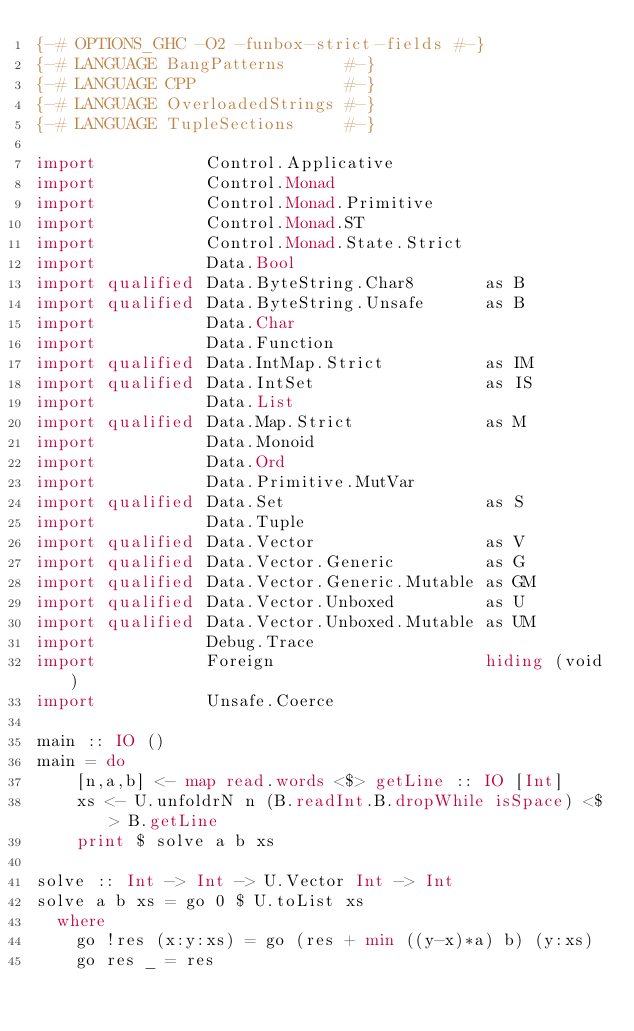Convert code to text. <code><loc_0><loc_0><loc_500><loc_500><_Haskell_>{-# OPTIONS_GHC -O2 -funbox-strict-fields #-}
{-# LANGUAGE BangPatterns      #-}
{-# LANGUAGE CPP               #-}
{-# LANGUAGE OverloadedStrings #-}
{-# LANGUAGE TupleSections     #-}

import           Control.Applicative
import           Control.Monad
import           Control.Monad.Primitive
import           Control.Monad.ST
import           Control.Monad.State.Strict
import           Data.Bool
import qualified Data.ByteString.Char8       as B
import qualified Data.ByteString.Unsafe      as B
import           Data.Char
import           Data.Function
import qualified Data.IntMap.Strict          as IM
import qualified Data.IntSet                 as IS
import           Data.List
import qualified Data.Map.Strict             as M
import           Data.Monoid
import           Data.Ord
import           Data.Primitive.MutVar
import qualified Data.Set                    as S
import           Data.Tuple
import qualified Data.Vector                 as V
import qualified Data.Vector.Generic         as G
import qualified Data.Vector.Generic.Mutable as GM
import qualified Data.Vector.Unboxed         as U
import qualified Data.Vector.Unboxed.Mutable as UM
import           Debug.Trace
import           Foreign                     hiding (void)
import           Unsafe.Coerce

main :: IO ()
main = do
    [n,a,b] <- map read.words <$> getLine :: IO [Int]
    xs <- U.unfoldrN n (B.readInt.B.dropWhile isSpace) <$> B.getLine
    print $ solve a b xs

solve :: Int -> Int -> U.Vector Int -> Int
solve a b xs = go 0 $ U.toList xs
  where
    go !res (x:y:xs) = go (res + min ((y-x)*a) b) (y:xs)
    go res _ = res</code> 